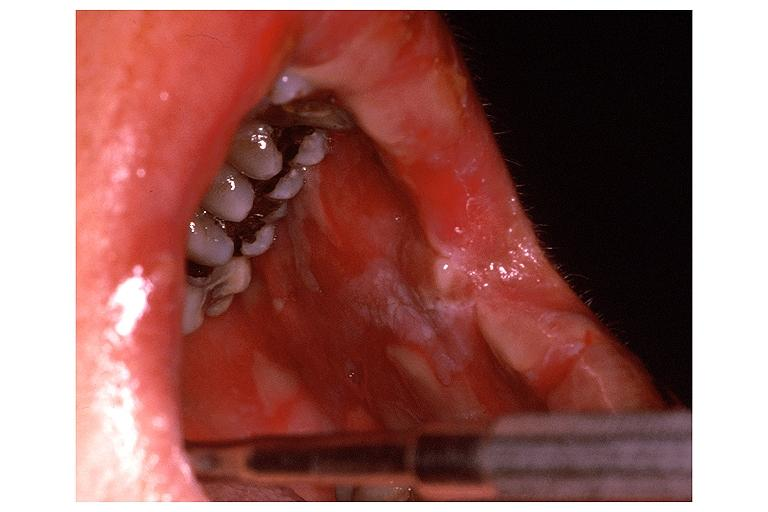what is present?
Answer the question using a single word or phrase. Oral 